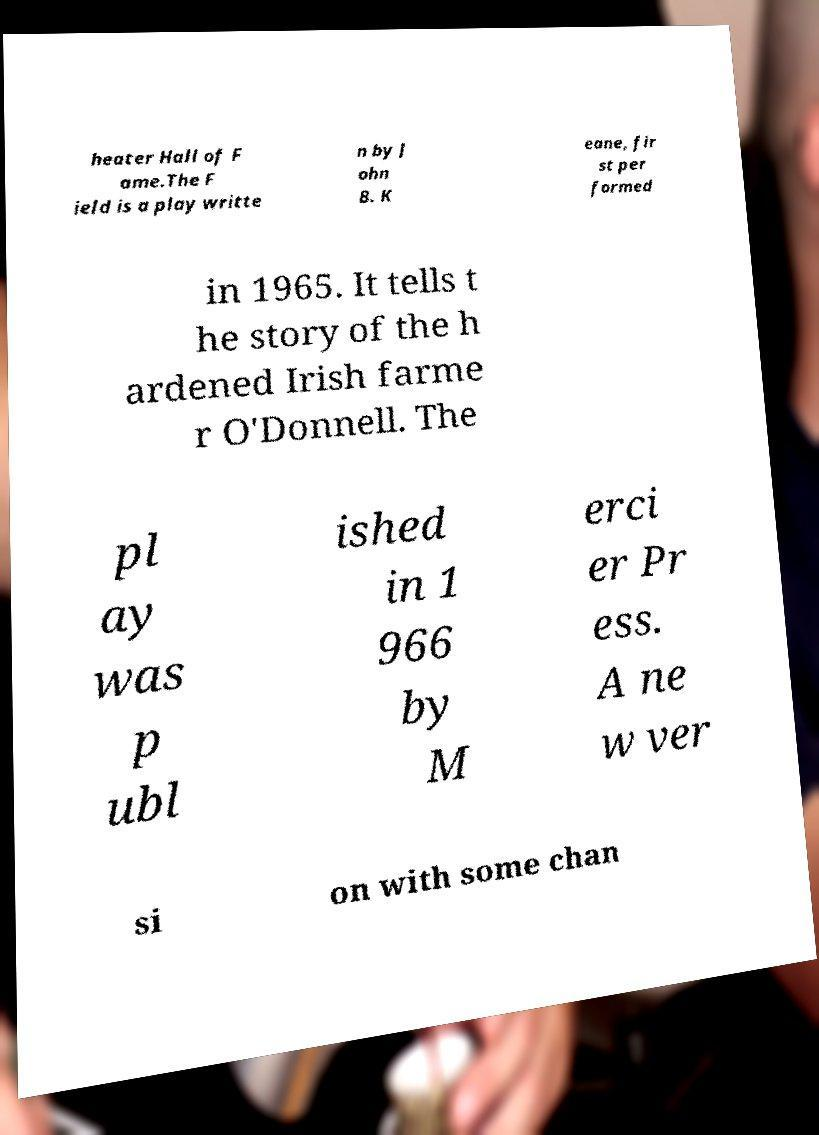There's text embedded in this image that I need extracted. Can you transcribe it verbatim? heater Hall of F ame.The F ield is a play writte n by J ohn B. K eane, fir st per formed in 1965. It tells t he story of the h ardened Irish farme r O'Donnell. The pl ay was p ubl ished in 1 966 by M erci er Pr ess. A ne w ver si on with some chan 